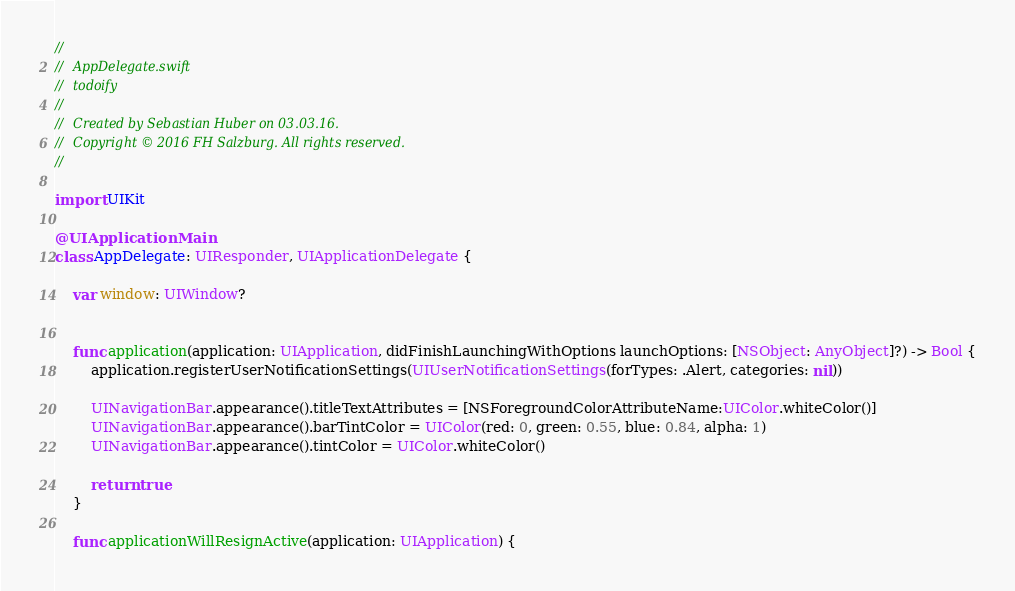<code> <loc_0><loc_0><loc_500><loc_500><_Swift_>//
//  AppDelegate.swift
//  todoify
//
//  Created by Sebastian Huber on 03.03.16.
//  Copyright © 2016 FH Salzburg. All rights reserved.
//

import UIKit

@UIApplicationMain
class AppDelegate: UIResponder, UIApplicationDelegate {

    var window: UIWindow?


    func application(application: UIApplication, didFinishLaunchingWithOptions launchOptions: [NSObject: AnyObject]?) -> Bool {
        application.registerUserNotificationSettings(UIUserNotificationSettings(forTypes: .Alert, categories: nil))
                
        UINavigationBar.appearance().titleTextAttributes = [NSForegroundColorAttributeName:UIColor.whiteColor()]
        UINavigationBar.appearance().barTintColor = UIColor(red: 0, green: 0.55, blue: 0.84, alpha: 1)
        UINavigationBar.appearance().tintColor = UIColor.whiteColor()
        
        return true
    }

    func applicationWillResignActive(application: UIApplication) {</code> 